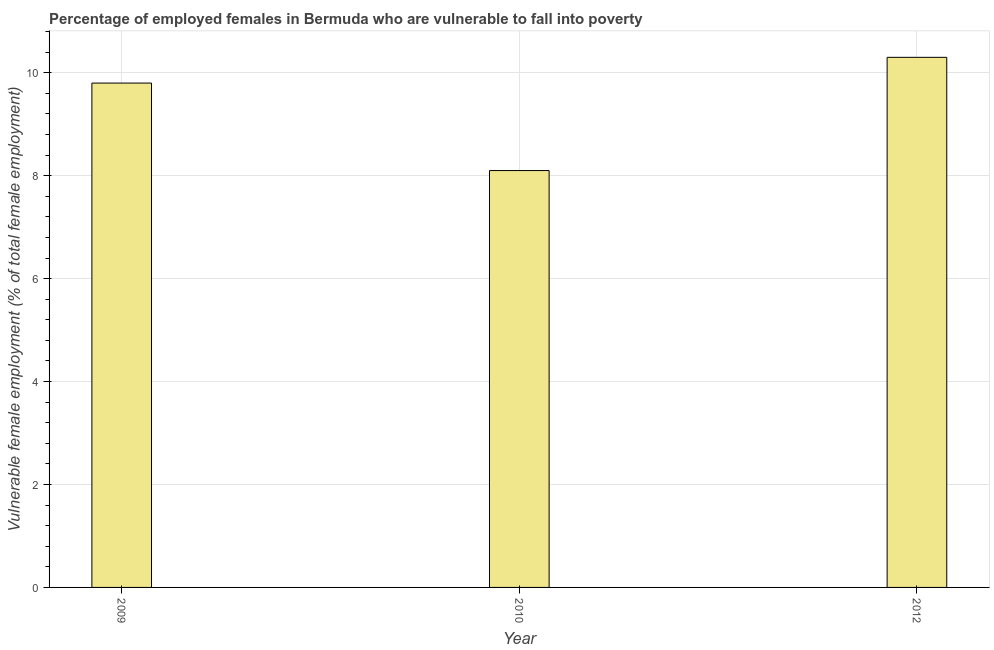Does the graph contain grids?
Provide a succinct answer. Yes. What is the title of the graph?
Offer a very short reply. Percentage of employed females in Bermuda who are vulnerable to fall into poverty. What is the label or title of the X-axis?
Keep it short and to the point. Year. What is the label or title of the Y-axis?
Your answer should be very brief. Vulnerable female employment (% of total female employment). What is the percentage of employed females who are vulnerable to fall into poverty in 2009?
Keep it short and to the point. 9.8. Across all years, what is the maximum percentage of employed females who are vulnerable to fall into poverty?
Your answer should be compact. 10.3. Across all years, what is the minimum percentage of employed females who are vulnerable to fall into poverty?
Provide a short and direct response. 8.1. What is the sum of the percentage of employed females who are vulnerable to fall into poverty?
Ensure brevity in your answer.  28.2. What is the average percentage of employed females who are vulnerable to fall into poverty per year?
Offer a very short reply. 9.4. What is the median percentage of employed females who are vulnerable to fall into poverty?
Offer a very short reply. 9.8. In how many years, is the percentage of employed females who are vulnerable to fall into poverty greater than 2 %?
Make the answer very short. 3. What is the ratio of the percentage of employed females who are vulnerable to fall into poverty in 2010 to that in 2012?
Ensure brevity in your answer.  0.79. Is the difference between the percentage of employed females who are vulnerable to fall into poverty in 2009 and 2010 greater than the difference between any two years?
Keep it short and to the point. No. Is the sum of the percentage of employed females who are vulnerable to fall into poverty in 2009 and 2012 greater than the maximum percentage of employed females who are vulnerable to fall into poverty across all years?
Offer a terse response. Yes. In how many years, is the percentage of employed females who are vulnerable to fall into poverty greater than the average percentage of employed females who are vulnerable to fall into poverty taken over all years?
Make the answer very short. 2. How many bars are there?
Give a very brief answer. 3. Are all the bars in the graph horizontal?
Keep it short and to the point. No. How many years are there in the graph?
Your response must be concise. 3. What is the difference between two consecutive major ticks on the Y-axis?
Your answer should be compact. 2. Are the values on the major ticks of Y-axis written in scientific E-notation?
Provide a short and direct response. No. What is the Vulnerable female employment (% of total female employment) in 2009?
Ensure brevity in your answer.  9.8. What is the Vulnerable female employment (% of total female employment) in 2010?
Your answer should be compact. 8.1. What is the Vulnerable female employment (% of total female employment) of 2012?
Provide a succinct answer. 10.3. What is the ratio of the Vulnerable female employment (% of total female employment) in 2009 to that in 2010?
Offer a very short reply. 1.21. What is the ratio of the Vulnerable female employment (% of total female employment) in 2009 to that in 2012?
Offer a very short reply. 0.95. What is the ratio of the Vulnerable female employment (% of total female employment) in 2010 to that in 2012?
Offer a very short reply. 0.79. 